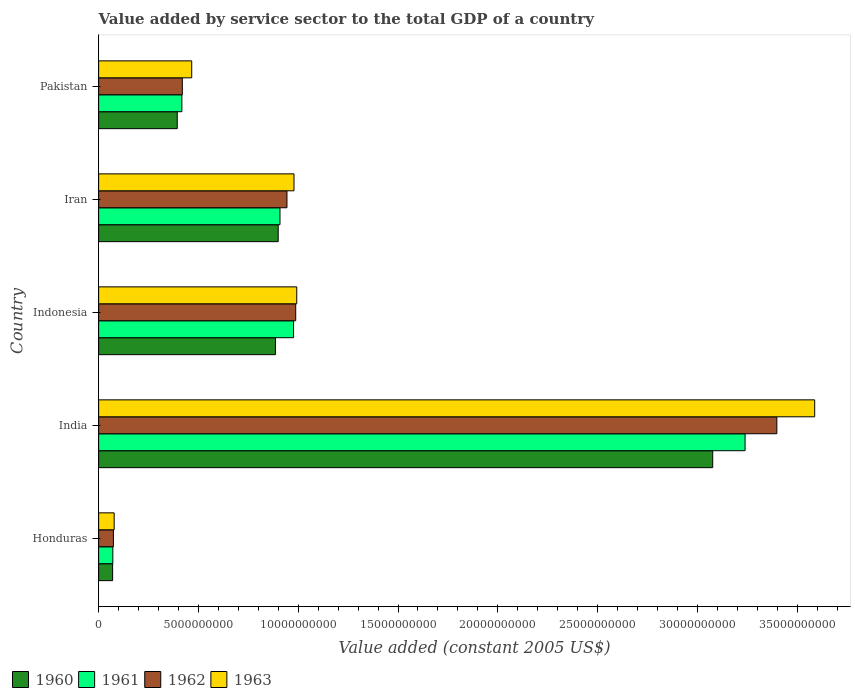How many groups of bars are there?
Your answer should be very brief. 5. Are the number of bars on each tick of the Y-axis equal?
Make the answer very short. Yes. How many bars are there on the 5th tick from the top?
Offer a very short reply. 4. What is the label of the 2nd group of bars from the top?
Make the answer very short. Iran. In how many cases, is the number of bars for a given country not equal to the number of legend labels?
Offer a very short reply. 0. What is the value added by service sector in 1963 in India?
Your response must be concise. 3.59e+1. Across all countries, what is the maximum value added by service sector in 1961?
Your response must be concise. 3.24e+1. Across all countries, what is the minimum value added by service sector in 1963?
Your answer should be very brief. 7.78e+08. In which country was the value added by service sector in 1960 minimum?
Offer a very short reply. Honduras. What is the total value added by service sector in 1963 in the graph?
Your answer should be compact. 6.10e+1. What is the difference between the value added by service sector in 1962 in India and that in Iran?
Ensure brevity in your answer.  2.45e+1. What is the difference between the value added by service sector in 1960 in Honduras and the value added by service sector in 1961 in Iran?
Ensure brevity in your answer.  -8.39e+09. What is the average value added by service sector in 1962 per country?
Provide a succinct answer. 1.16e+1. What is the difference between the value added by service sector in 1963 and value added by service sector in 1962 in Pakistan?
Your answer should be compact. 4.71e+08. In how many countries, is the value added by service sector in 1962 greater than 15000000000 US$?
Your answer should be very brief. 1. What is the ratio of the value added by service sector in 1962 in Indonesia to that in Iran?
Give a very brief answer. 1.05. Is the value added by service sector in 1962 in India less than that in Iran?
Your response must be concise. No. Is the difference between the value added by service sector in 1963 in Honduras and Iran greater than the difference between the value added by service sector in 1962 in Honduras and Iran?
Offer a very short reply. No. What is the difference between the highest and the second highest value added by service sector in 1962?
Offer a terse response. 2.41e+1. What is the difference between the highest and the lowest value added by service sector in 1961?
Your answer should be very brief. 3.17e+1. Is it the case that in every country, the sum of the value added by service sector in 1960 and value added by service sector in 1961 is greater than the value added by service sector in 1963?
Your response must be concise. Yes. What is the difference between two consecutive major ticks on the X-axis?
Your answer should be compact. 5.00e+09. Does the graph contain any zero values?
Provide a short and direct response. No. Does the graph contain grids?
Provide a succinct answer. No. Where does the legend appear in the graph?
Give a very brief answer. Bottom left. How many legend labels are there?
Keep it short and to the point. 4. What is the title of the graph?
Offer a terse response. Value added by service sector to the total GDP of a country. What is the label or title of the X-axis?
Provide a succinct answer. Value added (constant 2005 US$). What is the label or title of the Y-axis?
Offer a very short reply. Country. What is the Value added (constant 2005 US$) in 1960 in Honduras?
Provide a short and direct response. 7.01e+08. What is the Value added (constant 2005 US$) of 1961 in Honduras?
Provide a short and direct response. 7.12e+08. What is the Value added (constant 2005 US$) of 1962 in Honduras?
Make the answer very short. 7.41e+08. What is the Value added (constant 2005 US$) of 1963 in Honduras?
Your response must be concise. 7.78e+08. What is the Value added (constant 2005 US$) in 1960 in India?
Your answer should be compact. 3.08e+1. What is the Value added (constant 2005 US$) of 1961 in India?
Your answer should be compact. 3.24e+1. What is the Value added (constant 2005 US$) of 1962 in India?
Provide a short and direct response. 3.40e+1. What is the Value added (constant 2005 US$) of 1963 in India?
Your response must be concise. 3.59e+1. What is the Value added (constant 2005 US$) of 1960 in Indonesia?
Provide a short and direct response. 8.86e+09. What is the Value added (constant 2005 US$) of 1961 in Indonesia?
Offer a very short reply. 9.77e+09. What is the Value added (constant 2005 US$) of 1962 in Indonesia?
Provide a succinct answer. 9.88e+09. What is the Value added (constant 2005 US$) in 1963 in Indonesia?
Make the answer very short. 9.93e+09. What is the Value added (constant 2005 US$) in 1960 in Iran?
Make the answer very short. 9.00e+09. What is the Value added (constant 2005 US$) in 1961 in Iran?
Provide a succinct answer. 9.09e+09. What is the Value added (constant 2005 US$) of 1962 in Iran?
Keep it short and to the point. 9.44e+09. What is the Value added (constant 2005 US$) of 1963 in Iran?
Offer a terse response. 9.79e+09. What is the Value added (constant 2005 US$) of 1960 in Pakistan?
Keep it short and to the point. 3.94e+09. What is the Value added (constant 2005 US$) of 1961 in Pakistan?
Ensure brevity in your answer.  4.17e+09. What is the Value added (constant 2005 US$) of 1962 in Pakistan?
Offer a very short reply. 4.19e+09. What is the Value added (constant 2005 US$) of 1963 in Pakistan?
Your answer should be very brief. 4.66e+09. Across all countries, what is the maximum Value added (constant 2005 US$) in 1960?
Provide a succinct answer. 3.08e+1. Across all countries, what is the maximum Value added (constant 2005 US$) of 1961?
Make the answer very short. 3.24e+1. Across all countries, what is the maximum Value added (constant 2005 US$) of 1962?
Keep it short and to the point. 3.40e+1. Across all countries, what is the maximum Value added (constant 2005 US$) in 1963?
Your response must be concise. 3.59e+1. Across all countries, what is the minimum Value added (constant 2005 US$) of 1960?
Your response must be concise. 7.01e+08. Across all countries, what is the minimum Value added (constant 2005 US$) in 1961?
Your answer should be very brief. 7.12e+08. Across all countries, what is the minimum Value added (constant 2005 US$) of 1962?
Provide a short and direct response. 7.41e+08. Across all countries, what is the minimum Value added (constant 2005 US$) in 1963?
Your answer should be very brief. 7.78e+08. What is the total Value added (constant 2005 US$) of 1960 in the graph?
Provide a short and direct response. 5.33e+1. What is the total Value added (constant 2005 US$) in 1961 in the graph?
Your answer should be very brief. 5.61e+1. What is the total Value added (constant 2005 US$) in 1962 in the graph?
Ensure brevity in your answer.  5.82e+1. What is the total Value added (constant 2005 US$) in 1963 in the graph?
Provide a short and direct response. 6.10e+1. What is the difference between the Value added (constant 2005 US$) of 1960 in Honduras and that in India?
Give a very brief answer. -3.01e+1. What is the difference between the Value added (constant 2005 US$) of 1961 in Honduras and that in India?
Provide a short and direct response. -3.17e+1. What is the difference between the Value added (constant 2005 US$) of 1962 in Honduras and that in India?
Give a very brief answer. -3.32e+1. What is the difference between the Value added (constant 2005 US$) in 1963 in Honduras and that in India?
Ensure brevity in your answer.  -3.51e+1. What is the difference between the Value added (constant 2005 US$) in 1960 in Honduras and that in Indonesia?
Provide a short and direct response. -8.16e+09. What is the difference between the Value added (constant 2005 US$) of 1961 in Honduras and that in Indonesia?
Make the answer very short. -9.05e+09. What is the difference between the Value added (constant 2005 US$) in 1962 in Honduras and that in Indonesia?
Provide a short and direct response. -9.13e+09. What is the difference between the Value added (constant 2005 US$) of 1963 in Honduras and that in Indonesia?
Your answer should be compact. -9.15e+09. What is the difference between the Value added (constant 2005 US$) in 1960 in Honduras and that in Iran?
Keep it short and to the point. -8.30e+09. What is the difference between the Value added (constant 2005 US$) of 1961 in Honduras and that in Iran?
Offer a very short reply. -8.37e+09. What is the difference between the Value added (constant 2005 US$) in 1962 in Honduras and that in Iran?
Your answer should be very brief. -8.70e+09. What is the difference between the Value added (constant 2005 US$) of 1963 in Honduras and that in Iran?
Offer a terse response. -9.01e+09. What is the difference between the Value added (constant 2005 US$) of 1960 in Honduras and that in Pakistan?
Your answer should be compact. -3.24e+09. What is the difference between the Value added (constant 2005 US$) of 1961 in Honduras and that in Pakistan?
Give a very brief answer. -3.46e+09. What is the difference between the Value added (constant 2005 US$) of 1962 in Honduras and that in Pakistan?
Offer a very short reply. -3.45e+09. What is the difference between the Value added (constant 2005 US$) in 1963 in Honduras and that in Pakistan?
Provide a short and direct response. -3.89e+09. What is the difference between the Value added (constant 2005 US$) of 1960 in India and that in Indonesia?
Make the answer very short. 2.19e+1. What is the difference between the Value added (constant 2005 US$) in 1961 in India and that in Indonesia?
Offer a terse response. 2.26e+1. What is the difference between the Value added (constant 2005 US$) of 1962 in India and that in Indonesia?
Offer a terse response. 2.41e+1. What is the difference between the Value added (constant 2005 US$) of 1963 in India and that in Indonesia?
Your answer should be very brief. 2.60e+1. What is the difference between the Value added (constant 2005 US$) of 1960 in India and that in Iran?
Offer a very short reply. 2.18e+1. What is the difference between the Value added (constant 2005 US$) of 1961 in India and that in Iran?
Your answer should be compact. 2.33e+1. What is the difference between the Value added (constant 2005 US$) of 1962 in India and that in Iran?
Offer a very short reply. 2.45e+1. What is the difference between the Value added (constant 2005 US$) of 1963 in India and that in Iran?
Your response must be concise. 2.61e+1. What is the difference between the Value added (constant 2005 US$) of 1960 in India and that in Pakistan?
Your answer should be compact. 2.68e+1. What is the difference between the Value added (constant 2005 US$) in 1961 in India and that in Pakistan?
Your answer should be compact. 2.82e+1. What is the difference between the Value added (constant 2005 US$) of 1962 in India and that in Pakistan?
Provide a succinct answer. 2.98e+1. What is the difference between the Value added (constant 2005 US$) of 1963 in India and that in Pakistan?
Offer a very short reply. 3.12e+1. What is the difference between the Value added (constant 2005 US$) in 1960 in Indonesia and that in Iran?
Provide a short and direct response. -1.39e+08. What is the difference between the Value added (constant 2005 US$) of 1961 in Indonesia and that in Iran?
Your answer should be very brief. 6.80e+08. What is the difference between the Value added (constant 2005 US$) in 1962 in Indonesia and that in Iran?
Keep it short and to the point. 4.39e+08. What is the difference between the Value added (constant 2005 US$) in 1963 in Indonesia and that in Iran?
Your answer should be very brief. 1.38e+08. What is the difference between the Value added (constant 2005 US$) in 1960 in Indonesia and that in Pakistan?
Your answer should be very brief. 4.92e+09. What is the difference between the Value added (constant 2005 US$) of 1961 in Indonesia and that in Pakistan?
Make the answer very short. 5.60e+09. What is the difference between the Value added (constant 2005 US$) of 1962 in Indonesia and that in Pakistan?
Provide a succinct answer. 5.68e+09. What is the difference between the Value added (constant 2005 US$) of 1963 in Indonesia and that in Pakistan?
Ensure brevity in your answer.  5.26e+09. What is the difference between the Value added (constant 2005 US$) in 1960 in Iran and that in Pakistan?
Offer a terse response. 5.06e+09. What is the difference between the Value added (constant 2005 US$) of 1961 in Iran and that in Pakistan?
Make the answer very short. 4.92e+09. What is the difference between the Value added (constant 2005 US$) of 1962 in Iran and that in Pakistan?
Your response must be concise. 5.24e+09. What is the difference between the Value added (constant 2005 US$) of 1963 in Iran and that in Pakistan?
Your answer should be very brief. 5.12e+09. What is the difference between the Value added (constant 2005 US$) of 1960 in Honduras and the Value added (constant 2005 US$) of 1961 in India?
Keep it short and to the point. -3.17e+1. What is the difference between the Value added (constant 2005 US$) of 1960 in Honduras and the Value added (constant 2005 US$) of 1962 in India?
Keep it short and to the point. -3.33e+1. What is the difference between the Value added (constant 2005 US$) of 1960 in Honduras and the Value added (constant 2005 US$) of 1963 in India?
Your answer should be very brief. -3.52e+1. What is the difference between the Value added (constant 2005 US$) of 1961 in Honduras and the Value added (constant 2005 US$) of 1962 in India?
Your response must be concise. -3.33e+1. What is the difference between the Value added (constant 2005 US$) of 1961 in Honduras and the Value added (constant 2005 US$) of 1963 in India?
Provide a succinct answer. -3.52e+1. What is the difference between the Value added (constant 2005 US$) of 1962 in Honduras and the Value added (constant 2005 US$) of 1963 in India?
Offer a terse response. -3.51e+1. What is the difference between the Value added (constant 2005 US$) in 1960 in Honduras and the Value added (constant 2005 US$) in 1961 in Indonesia?
Keep it short and to the point. -9.07e+09. What is the difference between the Value added (constant 2005 US$) of 1960 in Honduras and the Value added (constant 2005 US$) of 1962 in Indonesia?
Your response must be concise. -9.17e+09. What is the difference between the Value added (constant 2005 US$) of 1960 in Honduras and the Value added (constant 2005 US$) of 1963 in Indonesia?
Offer a very short reply. -9.23e+09. What is the difference between the Value added (constant 2005 US$) of 1961 in Honduras and the Value added (constant 2005 US$) of 1962 in Indonesia?
Your answer should be very brief. -9.16e+09. What is the difference between the Value added (constant 2005 US$) in 1961 in Honduras and the Value added (constant 2005 US$) in 1963 in Indonesia?
Ensure brevity in your answer.  -9.22e+09. What is the difference between the Value added (constant 2005 US$) in 1962 in Honduras and the Value added (constant 2005 US$) in 1963 in Indonesia?
Give a very brief answer. -9.19e+09. What is the difference between the Value added (constant 2005 US$) in 1960 in Honduras and the Value added (constant 2005 US$) in 1961 in Iran?
Your answer should be compact. -8.39e+09. What is the difference between the Value added (constant 2005 US$) in 1960 in Honduras and the Value added (constant 2005 US$) in 1962 in Iran?
Offer a very short reply. -8.73e+09. What is the difference between the Value added (constant 2005 US$) in 1960 in Honduras and the Value added (constant 2005 US$) in 1963 in Iran?
Your response must be concise. -9.09e+09. What is the difference between the Value added (constant 2005 US$) in 1961 in Honduras and the Value added (constant 2005 US$) in 1962 in Iran?
Offer a very short reply. -8.72e+09. What is the difference between the Value added (constant 2005 US$) in 1961 in Honduras and the Value added (constant 2005 US$) in 1963 in Iran?
Keep it short and to the point. -9.08e+09. What is the difference between the Value added (constant 2005 US$) in 1962 in Honduras and the Value added (constant 2005 US$) in 1963 in Iran?
Your response must be concise. -9.05e+09. What is the difference between the Value added (constant 2005 US$) in 1960 in Honduras and the Value added (constant 2005 US$) in 1961 in Pakistan?
Your answer should be compact. -3.47e+09. What is the difference between the Value added (constant 2005 US$) in 1960 in Honduras and the Value added (constant 2005 US$) in 1962 in Pakistan?
Offer a very short reply. -3.49e+09. What is the difference between the Value added (constant 2005 US$) of 1960 in Honduras and the Value added (constant 2005 US$) of 1963 in Pakistan?
Your answer should be very brief. -3.96e+09. What is the difference between the Value added (constant 2005 US$) of 1961 in Honduras and the Value added (constant 2005 US$) of 1962 in Pakistan?
Provide a short and direct response. -3.48e+09. What is the difference between the Value added (constant 2005 US$) of 1961 in Honduras and the Value added (constant 2005 US$) of 1963 in Pakistan?
Provide a succinct answer. -3.95e+09. What is the difference between the Value added (constant 2005 US$) in 1962 in Honduras and the Value added (constant 2005 US$) in 1963 in Pakistan?
Offer a terse response. -3.92e+09. What is the difference between the Value added (constant 2005 US$) in 1960 in India and the Value added (constant 2005 US$) in 1961 in Indonesia?
Make the answer very short. 2.10e+1. What is the difference between the Value added (constant 2005 US$) of 1960 in India and the Value added (constant 2005 US$) of 1962 in Indonesia?
Your answer should be compact. 2.09e+1. What is the difference between the Value added (constant 2005 US$) of 1960 in India and the Value added (constant 2005 US$) of 1963 in Indonesia?
Your answer should be compact. 2.08e+1. What is the difference between the Value added (constant 2005 US$) of 1961 in India and the Value added (constant 2005 US$) of 1962 in Indonesia?
Keep it short and to the point. 2.25e+1. What is the difference between the Value added (constant 2005 US$) of 1961 in India and the Value added (constant 2005 US$) of 1963 in Indonesia?
Offer a very short reply. 2.25e+1. What is the difference between the Value added (constant 2005 US$) in 1962 in India and the Value added (constant 2005 US$) in 1963 in Indonesia?
Your answer should be compact. 2.41e+1. What is the difference between the Value added (constant 2005 US$) in 1960 in India and the Value added (constant 2005 US$) in 1961 in Iran?
Provide a succinct answer. 2.17e+1. What is the difference between the Value added (constant 2005 US$) in 1960 in India and the Value added (constant 2005 US$) in 1962 in Iran?
Your answer should be compact. 2.13e+1. What is the difference between the Value added (constant 2005 US$) of 1960 in India and the Value added (constant 2005 US$) of 1963 in Iran?
Provide a succinct answer. 2.10e+1. What is the difference between the Value added (constant 2005 US$) in 1961 in India and the Value added (constant 2005 US$) in 1962 in Iran?
Offer a very short reply. 2.30e+1. What is the difference between the Value added (constant 2005 US$) of 1961 in India and the Value added (constant 2005 US$) of 1963 in Iran?
Keep it short and to the point. 2.26e+1. What is the difference between the Value added (constant 2005 US$) in 1962 in India and the Value added (constant 2005 US$) in 1963 in Iran?
Your response must be concise. 2.42e+1. What is the difference between the Value added (constant 2005 US$) of 1960 in India and the Value added (constant 2005 US$) of 1961 in Pakistan?
Provide a short and direct response. 2.66e+1. What is the difference between the Value added (constant 2005 US$) in 1960 in India and the Value added (constant 2005 US$) in 1962 in Pakistan?
Make the answer very short. 2.66e+1. What is the difference between the Value added (constant 2005 US$) of 1960 in India and the Value added (constant 2005 US$) of 1963 in Pakistan?
Give a very brief answer. 2.61e+1. What is the difference between the Value added (constant 2005 US$) in 1961 in India and the Value added (constant 2005 US$) in 1962 in Pakistan?
Your answer should be compact. 2.82e+1. What is the difference between the Value added (constant 2005 US$) of 1961 in India and the Value added (constant 2005 US$) of 1963 in Pakistan?
Offer a terse response. 2.77e+1. What is the difference between the Value added (constant 2005 US$) in 1962 in India and the Value added (constant 2005 US$) in 1963 in Pakistan?
Offer a very short reply. 2.93e+1. What is the difference between the Value added (constant 2005 US$) of 1960 in Indonesia and the Value added (constant 2005 US$) of 1961 in Iran?
Your answer should be compact. -2.28e+08. What is the difference between the Value added (constant 2005 US$) of 1960 in Indonesia and the Value added (constant 2005 US$) of 1962 in Iran?
Provide a short and direct response. -5.77e+08. What is the difference between the Value added (constant 2005 US$) of 1960 in Indonesia and the Value added (constant 2005 US$) of 1963 in Iran?
Your answer should be very brief. -9.30e+08. What is the difference between the Value added (constant 2005 US$) in 1961 in Indonesia and the Value added (constant 2005 US$) in 1962 in Iran?
Your answer should be compact. 3.30e+08. What is the difference between the Value added (constant 2005 US$) of 1961 in Indonesia and the Value added (constant 2005 US$) of 1963 in Iran?
Offer a very short reply. -2.20e+07. What is the difference between the Value added (constant 2005 US$) of 1962 in Indonesia and the Value added (constant 2005 US$) of 1963 in Iran?
Ensure brevity in your answer.  8.67e+07. What is the difference between the Value added (constant 2005 US$) of 1960 in Indonesia and the Value added (constant 2005 US$) of 1961 in Pakistan?
Provide a short and direct response. 4.69e+09. What is the difference between the Value added (constant 2005 US$) of 1960 in Indonesia and the Value added (constant 2005 US$) of 1962 in Pakistan?
Your answer should be compact. 4.66e+09. What is the difference between the Value added (constant 2005 US$) of 1960 in Indonesia and the Value added (constant 2005 US$) of 1963 in Pakistan?
Provide a succinct answer. 4.19e+09. What is the difference between the Value added (constant 2005 US$) of 1961 in Indonesia and the Value added (constant 2005 US$) of 1962 in Pakistan?
Your answer should be very brief. 5.57e+09. What is the difference between the Value added (constant 2005 US$) of 1961 in Indonesia and the Value added (constant 2005 US$) of 1963 in Pakistan?
Provide a short and direct response. 5.10e+09. What is the difference between the Value added (constant 2005 US$) in 1962 in Indonesia and the Value added (constant 2005 US$) in 1963 in Pakistan?
Provide a succinct answer. 5.21e+09. What is the difference between the Value added (constant 2005 US$) of 1960 in Iran and the Value added (constant 2005 US$) of 1961 in Pakistan?
Your response must be concise. 4.83e+09. What is the difference between the Value added (constant 2005 US$) in 1960 in Iran and the Value added (constant 2005 US$) in 1962 in Pakistan?
Ensure brevity in your answer.  4.80e+09. What is the difference between the Value added (constant 2005 US$) of 1960 in Iran and the Value added (constant 2005 US$) of 1963 in Pakistan?
Provide a succinct answer. 4.33e+09. What is the difference between the Value added (constant 2005 US$) of 1961 in Iran and the Value added (constant 2005 US$) of 1962 in Pakistan?
Your answer should be compact. 4.89e+09. What is the difference between the Value added (constant 2005 US$) of 1961 in Iran and the Value added (constant 2005 US$) of 1963 in Pakistan?
Make the answer very short. 4.42e+09. What is the difference between the Value added (constant 2005 US$) of 1962 in Iran and the Value added (constant 2005 US$) of 1963 in Pakistan?
Offer a very short reply. 4.77e+09. What is the average Value added (constant 2005 US$) in 1960 per country?
Your answer should be very brief. 1.07e+1. What is the average Value added (constant 2005 US$) in 1961 per country?
Make the answer very short. 1.12e+1. What is the average Value added (constant 2005 US$) of 1962 per country?
Provide a succinct answer. 1.16e+1. What is the average Value added (constant 2005 US$) in 1963 per country?
Your answer should be compact. 1.22e+1. What is the difference between the Value added (constant 2005 US$) of 1960 and Value added (constant 2005 US$) of 1961 in Honduras?
Offer a terse response. -1.04e+07. What is the difference between the Value added (constant 2005 US$) in 1960 and Value added (constant 2005 US$) in 1962 in Honduras?
Give a very brief answer. -3.93e+07. What is the difference between the Value added (constant 2005 US$) of 1960 and Value added (constant 2005 US$) of 1963 in Honduras?
Offer a very short reply. -7.65e+07. What is the difference between the Value added (constant 2005 US$) of 1961 and Value added (constant 2005 US$) of 1962 in Honduras?
Provide a short and direct response. -2.89e+07. What is the difference between the Value added (constant 2005 US$) of 1961 and Value added (constant 2005 US$) of 1963 in Honduras?
Provide a short and direct response. -6.62e+07. What is the difference between the Value added (constant 2005 US$) of 1962 and Value added (constant 2005 US$) of 1963 in Honduras?
Offer a terse response. -3.72e+07. What is the difference between the Value added (constant 2005 US$) of 1960 and Value added (constant 2005 US$) of 1961 in India?
Offer a very short reply. -1.62e+09. What is the difference between the Value added (constant 2005 US$) of 1960 and Value added (constant 2005 US$) of 1962 in India?
Ensure brevity in your answer.  -3.21e+09. What is the difference between the Value added (constant 2005 US$) of 1960 and Value added (constant 2005 US$) of 1963 in India?
Make the answer very short. -5.11e+09. What is the difference between the Value added (constant 2005 US$) of 1961 and Value added (constant 2005 US$) of 1962 in India?
Keep it short and to the point. -1.59e+09. What is the difference between the Value added (constant 2005 US$) of 1961 and Value added (constant 2005 US$) of 1963 in India?
Keep it short and to the point. -3.49e+09. What is the difference between the Value added (constant 2005 US$) in 1962 and Value added (constant 2005 US$) in 1963 in India?
Your answer should be very brief. -1.90e+09. What is the difference between the Value added (constant 2005 US$) in 1960 and Value added (constant 2005 US$) in 1961 in Indonesia?
Give a very brief answer. -9.08e+08. What is the difference between the Value added (constant 2005 US$) of 1960 and Value added (constant 2005 US$) of 1962 in Indonesia?
Your answer should be compact. -1.02e+09. What is the difference between the Value added (constant 2005 US$) of 1960 and Value added (constant 2005 US$) of 1963 in Indonesia?
Keep it short and to the point. -1.07e+09. What is the difference between the Value added (constant 2005 US$) in 1961 and Value added (constant 2005 US$) in 1962 in Indonesia?
Give a very brief answer. -1.09e+08. What is the difference between the Value added (constant 2005 US$) of 1961 and Value added (constant 2005 US$) of 1963 in Indonesia?
Offer a terse response. -1.60e+08. What is the difference between the Value added (constant 2005 US$) of 1962 and Value added (constant 2005 US$) of 1963 in Indonesia?
Your answer should be compact. -5.15e+07. What is the difference between the Value added (constant 2005 US$) in 1960 and Value added (constant 2005 US$) in 1961 in Iran?
Make the answer very short. -8.88e+07. What is the difference between the Value added (constant 2005 US$) of 1960 and Value added (constant 2005 US$) of 1962 in Iran?
Your answer should be compact. -4.39e+08. What is the difference between the Value added (constant 2005 US$) in 1960 and Value added (constant 2005 US$) in 1963 in Iran?
Offer a very short reply. -7.91e+08. What is the difference between the Value added (constant 2005 US$) in 1961 and Value added (constant 2005 US$) in 1962 in Iran?
Provide a short and direct response. -3.50e+08. What is the difference between the Value added (constant 2005 US$) in 1961 and Value added (constant 2005 US$) in 1963 in Iran?
Your answer should be compact. -7.02e+08. What is the difference between the Value added (constant 2005 US$) in 1962 and Value added (constant 2005 US$) in 1963 in Iran?
Your response must be concise. -3.52e+08. What is the difference between the Value added (constant 2005 US$) in 1960 and Value added (constant 2005 US$) in 1961 in Pakistan?
Provide a succinct answer. -2.32e+08. What is the difference between the Value added (constant 2005 US$) of 1960 and Value added (constant 2005 US$) of 1962 in Pakistan?
Your answer should be very brief. -2.54e+08. What is the difference between the Value added (constant 2005 US$) in 1960 and Value added (constant 2005 US$) in 1963 in Pakistan?
Provide a succinct answer. -7.25e+08. What is the difference between the Value added (constant 2005 US$) in 1961 and Value added (constant 2005 US$) in 1962 in Pakistan?
Ensure brevity in your answer.  -2.26e+07. What is the difference between the Value added (constant 2005 US$) of 1961 and Value added (constant 2005 US$) of 1963 in Pakistan?
Your answer should be very brief. -4.93e+08. What is the difference between the Value added (constant 2005 US$) in 1962 and Value added (constant 2005 US$) in 1963 in Pakistan?
Keep it short and to the point. -4.71e+08. What is the ratio of the Value added (constant 2005 US$) of 1960 in Honduras to that in India?
Provide a succinct answer. 0.02. What is the ratio of the Value added (constant 2005 US$) of 1961 in Honduras to that in India?
Offer a terse response. 0.02. What is the ratio of the Value added (constant 2005 US$) of 1962 in Honduras to that in India?
Ensure brevity in your answer.  0.02. What is the ratio of the Value added (constant 2005 US$) of 1963 in Honduras to that in India?
Offer a very short reply. 0.02. What is the ratio of the Value added (constant 2005 US$) of 1960 in Honduras to that in Indonesia?
Your answer should be very brief. 0.08. What is the ratio of the Value added (constant 2005 US$) of 1961 in Honduras to that in Indonesia?
Give a very brief answer. 0.07. What is the ratio of the Value added (constant 2005 US$) of 1962 in Honduras to that in Indonesia?
Offer a terse response. 0.07. What is the ratio of the Value added (constant 2005 US$) in 1963 in Honduras to that in Indonesia?
Give a very brief answer. 0.08. What is the ratio of the Value added (constant 2005 US$) of 1960 in Honduras to that in Iran?
Your answer should be compact. 0.08. What is the ratio of the Value added (constant 2005 US$) of 1961 in Honduras to that in Iran?
Your answer should be compact. 0.08. What is the ratio of the Value added (constant 2005 US$) of 1962 in Honduras to that in Iran?
Provide a succinct answer. 0.08. What is the ratio of the Value added (constant 2005 US$) in 1963 in Honduras to that in Iran?
Your response must be concise. 0.08. What is the ratio of the Value added (constant 2005 US$) in 1960 in Honduras to that in Pakistan?
Provide a short and direct response. 0.18. What is the ratio of the Value added (constant 2005 US$) in 1961 in Honduras to that in Pakistan?
Offer a very short reply. 0.17. What is the ratio of the Value added (constant 2005 US$) of 1962 in Honduras to that in Pakistan?
Your answer should be very brief. 0.18. What is the ratio of the Value added (constant 2005 US$) of 1963 in Honduras to that in Pakistan?
Offer a very short reply. 0.17. What is the ratio of the Value added (constant 2005 US$) in 1960 in India to that in Indonesia?
Provide a succinct answer. 3.47. What is the ratio of the Value added (constant 2005 US$) in 1961 in India to that in Indonesia?
Offer a very short reply. 3.32. What is the ratio of the Value added (constant 2005 US$) of 1962 in India to that in Indonesia?
Keep it short and to the point. 3.44. What is the ratio of the Value added (constant 2005 US$) of 1963 in India to that in Indonesia?
Give a very brief answer. 3.61. What is the ratio of the Value added (constant 2005 US$) of 1960 in India to that in Iran?
Provide a short and direct response. 3.42. What is the ratio of the Value added (constant 2005 US$) in 1961 in India to that in Iran?
Ensure brevity in your answer.  3.56. What is the ratio of the Value added (constant 2005 US$) in 1962 in India to that in Iran?
Offer a very short reply. 3.6. What is the ratio of the Value added (constant 2005 US$) in 1963 in India to that in Iran?
Offer a very short reply. 3.67. What is the ratio of the Value added (constant 2005 US$) in 1960 in India to that in Pakistan?
Your answer should be very brief. 7.81. What is the ratio of the Value added (constant 2005 US$) of 1961 in India to that in Pakistan?
Your answer should be compact. 7.77. What is the ratio of the Value added (constant 2005 US$) in 1962 in India to that in Pakistan?
Provide a short and direct response. 8.1. What is the ratio of the Value added (constant 2005 US$) of 1963 in India to that in Pakistan?
Provide a succinct answer. 7.69. What is the ratio of the Value added (constant 2005 US$) of 1960 in Indonesia to that in Iran?
Offer a terse response. 0.98. What is the ratio of the Value added (constant 2005 US$) of 1961 in Indonesia to that in Iran?
Ensure brevity in your answer.  1.07. What is the ratio of the Value added (constant 2005 US$) of 1962 in Indonesia to that in Iran?
Your answer should be very brief. 1.05. What is the ratio of the Value added (constant 2005 US$) in 1963 in Indonesia to that in Iran?
Ensure brevity in your answer.  1.01. What is the ratio of the Value added (constant 2005 US$) in 1960 in Indonesia to that in Pakistan?
Provide a short and direct response. 2.25. What is the ratio of the Value added (constant 2005 US$) in 1961 in Indonesia to that in Pakistan?
Ensure brevity in your answer.  2.34. What is the ratio of the Value added (constant 2005 US$) of 1962 in Indonesia to that in Pakistan?
Give a very brief answer. 2.35. What is the ratio of the Value added (constant 2005 US$) of 1963 in Indonesia to that in Pakistan?
Offer a very short reply. 2.13. What is the ratio of the Value added (constant 2005 US$) in 1960 in Iran to that in Pakistan?
Offer a terse response. 2.28. What is the ratio of the Value added (constant 2005 US$) in 1961 in Iran to that in Pakistan?
Your answer should be very brief. 2.18. What is the ratio of the Value added (constant 2005 US$) in 1962 in Iran to that in Pakistan?
Offer a terse response. 2.25. What is the ratio of the Value added (constant 2005 US$) in 1963 in Iran to that in Pakistan?
Your response must be concise. 2.1. What is the difference between the highest and the second highest Value added (constant 2005 US$) in 1960?
Ensure brevity in your answer.  2.18e+1. What is the difference between the highest and the second highest Value added (constant 2005 US$) in 1961?
Your answer should be very brief. 2.26e+1. What is the difference between the highest and the second highest Value added (constant 2005 US$) in 1962?
Your response must be concise. 2.41e+1. What is the difference between the highest and the second highest Value added (constant 2005 US$) of 1963?
Your answer should be very brief. 2.60e+1. What is the difference between the highest and the lowest Value added (constant 2005 US$) of 1960?
Offer a very short reply. 3.01e+1. What is the difference between the highest and the lowest Value added (constant 2005 US$) in 1961?
Offer a very short reply. 3.17e+1. What is the difference between the highest and the lowest Value added (constant 2005 US$) of 1962?
Your response must be concise. 3.32e+1. What is the difference between the highest and the lowest Value added (constant 2005 US$) of 1963?
Make the answer very short. 3.51e+1. 